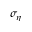<formula> <loc_0><loc_0><loc_500><loc_500>\sigma _ { \eta }</formula> 